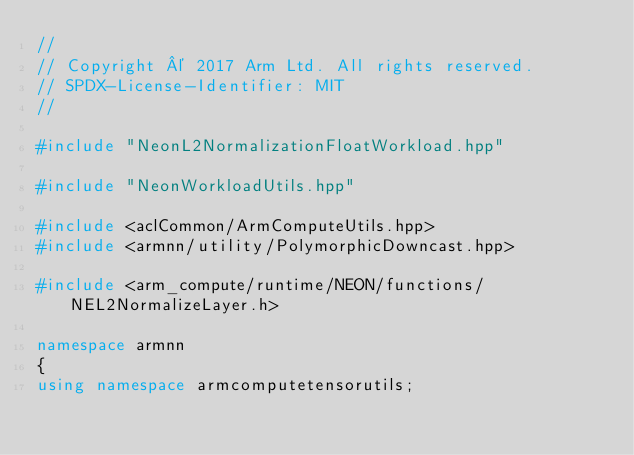Convert code to text. <code><loc_0><loc_0><loc_500><loc_500><_C++_>//
// Copyright © 2017 Arm Ltd. All rights reserved.
// SPDX-License-Identifier: MIT
//

#include "NeonL2NormalizationFloatWorkload.hpp"

#include "NeonWorkloadUtils.hpp"

#include <aclCommon/ArmComputeUtils.hpp>
#include <armnn/utility/PolymorphicDowncast.hpp>

#include <arm_compute/runtime/NEON/functions/NEL2NormalizeLayer.h>

namespace armnn
{
using namespace armcomputetensorutils;
</code> 